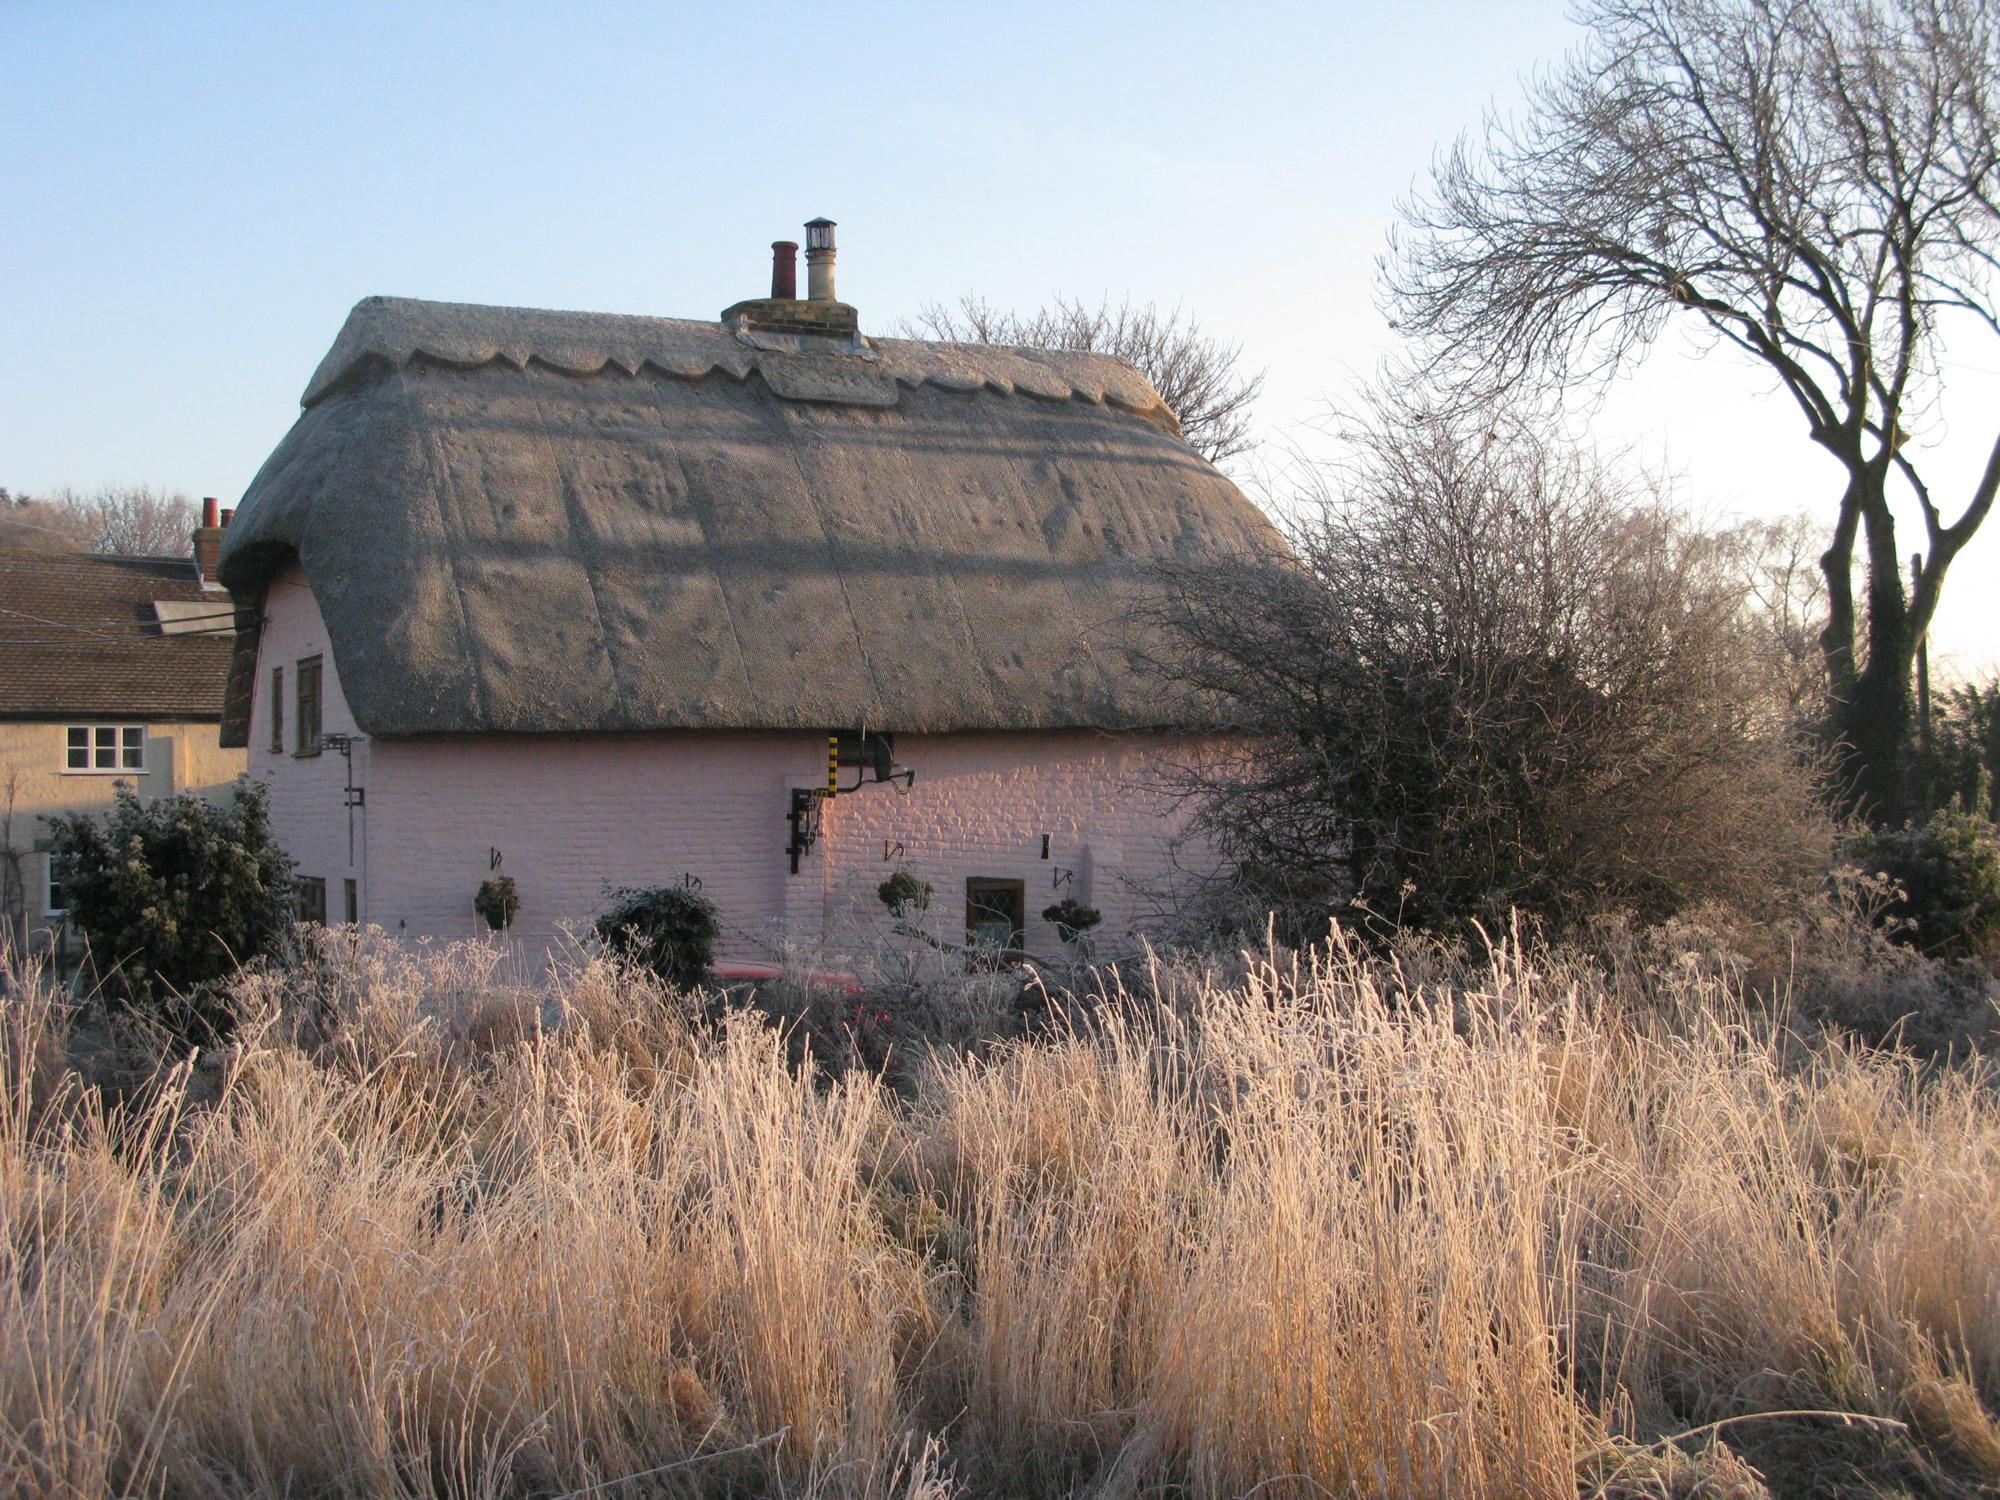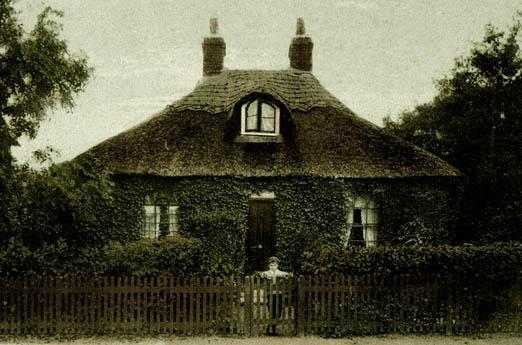The first image is the image on the left, the second image is the image on the right. For the images shown, is this caption "A fence is put up around the house on the right." true? Answer yes or no. Yes. The first image is the image on the left, the second image is the image on the right. Evaluate the accuracy of this statement regarding the images: "There are fewer than five chimneys.". Is it true? Answer yes or no. Yes. 